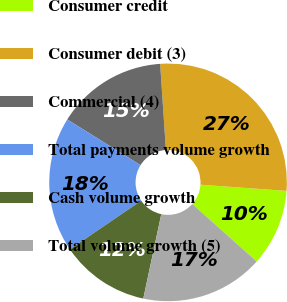Convert chart. <chart><loc_0><loc_0><loc_500><loc_500><pie_chart><fcel>Consumer credit<fcel>Consumer debit (3)<fcel>Commercial (4)<fcel>Total payments volume growth<fcel>Cash volume growth<fcel>Total volume growth (5)<nl><fcel>10.46%<fcel>27.2%<fcel>15.06%<fcel>18.41%<fcel>12.13%<fcel>16.74%<nl></chart> 